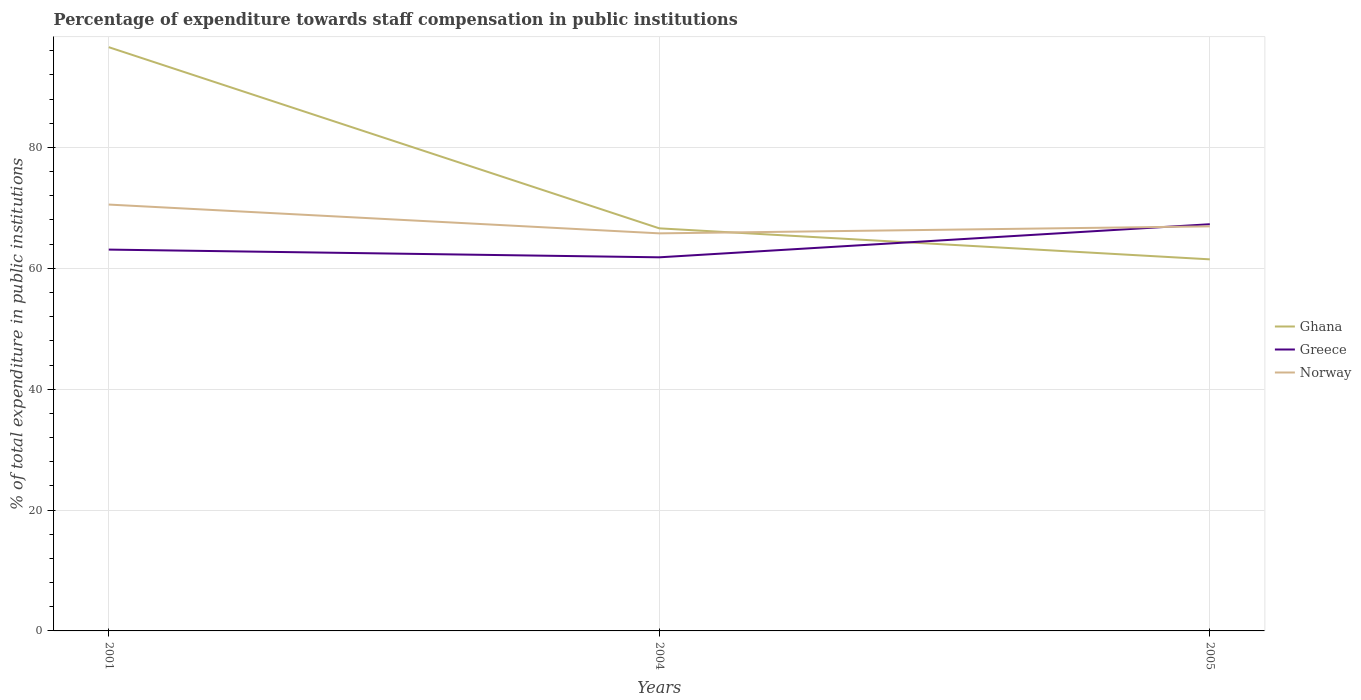Does the line corresponding to Greece intersect with the line corresponding to Ghana?
Provide a short and direct response. Yes. Across all years, what is the maximum percentage of expenditure towards staff compensation in Norway?
Offer a very short reply. 65.79. In which year was the percentage of expenditure towards staff compensation in Greece maximum?
Your answer should be compact. 2004. What is the total percentage of expenditure towards staff compensation in Greece in the graph?
Your answer should be compact. 1.28. What is the difference between the highest and the second highest percentage of expenditure towards staff compensation in Ghana?
Your answer should be compact. 35.11. What is the difference between the highest and the lowest percentage of expenditure towards staff compensation in Norway?
Provide a succinct answer. 1. Is the percentage of expenditure towards staff compensation in Greece strictly greater than the percentage of expenditure towards staff compensation in Ghana over the years?
Give a very brief answer. No. How many lines are there?
Provide a short and direct response. 3. How many years are there in the graph?
Your answer should be very brief. 3. What is the difference between two consecutive major ticks on the Y-axis?
Keep it short and to the point. 20. Does the graph contain any zero values?
Give a very brief answer. No. Does the graph contain grids?
Your answer should be compact. Yes. Where does the legend appear in the graph?
Your answer should be compact. Center right. How many legend labels are there?
Offer a terse response. 3. How are the legend labels stacked?
Your response must be concise. Vertical. What is the title of the graph?
Your response must be concise. Percentage of expenditure towards staff compensation in public institutions. What is the label or title of the Y-axis?
Your answer should be very brief. % of total expenditure in public institutions. What is the % of total expenditure in public institutions in Ghana in 2001?
Provide a succinct answer. 96.59. What is the % of total expenditure in public institutions in Greece in 2001?
Ensure brevity in your answer.  63.1. What is the % of total expenditure in public institutions of Norway in 2001?
Offer a very short reply. 70.55. What is the % of total expenditure in public institutions in Ghana in 2004?
Provide a short and direct response. 66.61. What is the % of total expenditure in public institutions of Greece in 2004?
Offer a terse response. 61.82. What is the % of total expenditure in public institutions in Norway in 2004?
Give a very brief answer. 65.79. What is the % of total expenditure in public institutions of Ghana in 2005?
Your answer should be very brief. 61.49. What is the % of total expenditure in public institutions of Greece in 2005?
Your response must be concise. 67.29. What is the % of total expenditure in public institutions of Norway in 2005?
Offer a very short reply. 66.94. Across all years, what is the maximum % of total expenditure in public institutions in Ghana?
Make the answer very short. 96.59. Across all years, what is the maximum % of total expenditure in public institutions in Greece?
Offer a very short reply. 67.29. Across all years, what is the maximum % of total expenditure in public institutions of Norway?
Offer a terse response. 70.55. Across all years, what is the minimum % of total expenditure in public institutions in Ghana?
Provide a succinct answer. 61.49. Across all years, what is the minimum % of total expenditure in public institutions in Greece?
Keep it short and to the point. 61.82. Across all years, what is the minimum % of total expenditure in public institutions of Norway?
Provide a succinct answer. 65.79. What is the total % of total expenditure in public institutions in Ghana in the graph?
Your response must be concise. 224.69. What is the total % of total expenditure in public institutions of Greece in the graph?
Provide a short and direct response. 192.21. What is the total % of total expenditure in public institutions of Norway in the graph?
Give a very brief answer. 203.28. What is the difference between the % of total expenditure in public institutions of Ghana in 2001 and that in 2004?
Keep it short and to the point. 29.98. What is the difference between the % of total expenditure in public institutions of Greece in 2001 and that in 2004?
Your answer should be compact. 1.28. What is the difference between the % of total expenditure in public institutions of Norway in 2001 and that in 2004?
Provide a succinct answer. 4.76. What is the difference between the % of total expenditure in public institutions of Ghana in 2001 and that in 2005?
Offer a very short reply. 35.11. What is the difference between the % of total expenditure in public institutions in Greece in 2001 and that in 2005?
Provide a short and direct response. -4.2. What is the difference between the % of total expenditure in public institutions in Norway in 2001 and that in 2005?
Make the answer very short. 3.61. What is the difference between the % of total expenditure in public institutions in Ghana in 2004 and that in 2005?
Offer a terse response. 5.13. What is the difference between the % of total expenditure in public institutions of Greece in 2004 and that in 2005?
Offer a very short reply. -5.47. What is the difference between the % of total expenditure in public institutions of Norway in 2004 and that in 2005?
Your answer should be very brief. -1.16. What is the difference between the % of total expenditure in public institutions in Ghana in 2001 and the % of total expenditure in public institutions in Greece in 2004?
Your answer should be very brief. 34.77. What is the difference between the % of total expenditure in public institutions of Ghana in 2001 and the % of total expenditure in public institutions of Norway in 2004?
Offer a terse response. 30.81. What is the difference between the % of total expenditure in public institutions in Greece in 2001 and the % of total expenditure in public institutions in Norway in 2004?
Make the answer very short. -2.69. What is the difference between the % of total expenditure in public institutions of Ghana in 2001 and the % of total expenditure in public institutions of Greece in 2005?
Your answer should be very brief. 29.3. What is the difference between the % of total expenditure in public institutions of Ghana in 2001 and the % of total expenditure in public institutions of Norway in 2005?
Keep it short and to the point. 29.65. What is the difference between the % of total expenditure in public institutions of Greece in 2001 and the % of total expenditure in public institutions of Norway in 2005?
Keep it short and to the point. -3.84. What is the difference between the % of total expenditure in public institutions of Ghana in 2004 and the % of total expenditure in public institutions of Greece in 2005?
Your answer should be compact. -0.68. What is the difference between the % of total expenditure in public institutions in Ghana in 2004 and the % of total expenditure in public institutions in Norway in 2005?
Your response must be concise. -0.33. What is the difference between the % of total expenditure in public institutions of Greece in 2004 and the % of total expenditure in public institutions of Norway in 2005?
Provide a short and direct response. -5.12. What is the average % of total expenditure in public institutions in Ghana per year?
Your response must be concise. 74.9. What is the average % of total expenditure in public institutions of Greece per year?
Give a very brief answer. 64.07. What is the average % of total expenditure in public institutions of Norway per year?
Offer a terse response. 67.76. In the year 2001, what is the difference between the % of total expenditure in public institutions of Ghana and % of total expenditure in public institutions of Greece?
Give a very brief answer. 33.49. In the year 2001, what is the difference between the % of total expenditure in public institutions of Ghana and % of total expenditure in public institutions of Norway?
Offer a terse response. 26.04. In the year 2001, what is the difference between the % of total expenditure in public institutions in Greece and % of total expenditure in public institutions in Norway?
Your answer should be compact. -7.45. In the year 2004, what is the difference between the % of total expenditure in public institutions in Ghana and % of total expenditure in public institutions in Greece?
Offer a very short reply. 4.79. In the year 2004, what is the difference between the % of total expenditure in public institutions in Ghana and % of total expenditure in public institutions in Norway?
Your answer should be very brief. 0.83. In the year 2004, what is the difference between the % of total expenditure in public institutions of Greece and % of total expenditure in public institutions of Norway?
Your response must be concise. -3.97. In the year 2005, what is the difference between the % of total expenditure in public institutions in Ghana and % of total expenditure in public institutions in Greece?
Your response must be concise. -5.81. In the year 2005, what is the difference between the % of total expenditure in public institutions of Ghana and % of total expenditure in public institutions of Norway?
Your response must be concise. -5.46. In the year 2005, what is the difference between the % of total expenditure in public institutions in Greece and % of total expenditure in public institutions in Norway?
Your answer should be very brief. 0.35. What is the ratio of the % of total expenditure in public institutions in Ghana in 2001 to that in 2004?
Give a very brief answer. 1.45. What is the ratio of the % of total expenditure in public institutions of Greece in 2001 to that in 2004?
Ensure brevity in your answer.  1.02. What is the ratio of the % of total expenditure in public institutions of Norway in 2001 to that in 2004?
Keep it short and to the point. 1.07. What is the ratio of the % of total expenditure in public institutions in Ghana in 2001 to that in 2005?
Ensure brevity in your answer.  1.57. What is the ratio of the % of total expenditure in public institutions in Greece in 2001 to that in 2005?
Your response must be concise. 0.94. What is the ratio of the % of total expenditure in public institutions in Norway in 2001 to that in 2005?
Your answer should be compact. 1.05. What is the ratio of the % of total expenditure in public institutions of Ghana in 2004 to that in 2005?
Give a very brief answer. 1.08. What is the ratio of the % of total expenditure in public institutions of Greece in 2004 to that in 2005?
Offer a very short reply. 0.92. What is the ratio of the % of total expenditure in public institutions of Norway in 2004 to that in 2005?
Your response must be concise. 0.98. What is the difference between the highest and the second highest % of total expenditure in public institutions of Ghana?
Offer a terse response. 29.98. What is the difference between the highest and the second highest % of total expenditure in public institutions of Greece?
Your answer should be compact. 4.2. What is the difference between the highest and the second highest % of total expenditure in public institutions in Norway?
Make the answer very short. 3.61. What is the difference between the highest and the lowest % of total expenditure in public institutions of Ghana?
Ensure brevity in your answer.  35.11. What is the difference between the highest and the lowest % of total expenditure in public institutions in Greece?
Provide a succinct answer. 5.47. What is the difference between the highest and the lowest % of total expenditure in public institutions of Norway?
Provide a succinct answer. 4.76. 